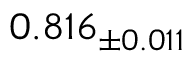<formula> <loc_0><loc_0><loc_500><loc_500>0 . 8 1 6 _ { \pm 0 . 0 1 1 }</formula> 